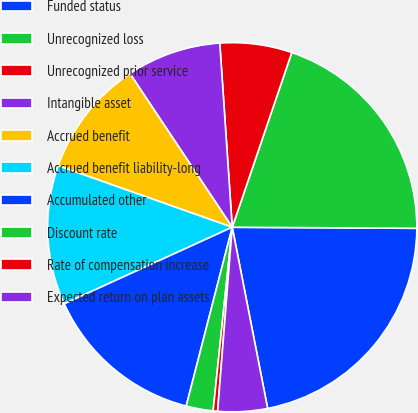Convert chart. <chart><loc_0><loc_0><loc_500><loc_500><pie_chart><fcel>Funded status<fcel>Unrecognized loss<fcel>Unrecognized prior service<fcel>Intangible asset<fcel>Accrued benefit<fcel>Accrued benefit liability-long<fcel>Accumulated other<fcel>Discount rate<fcel>Rate of compensation increase<fcel>Expected return on plan assets<nl><fcel>21.83%<fcel>19.86%<fcel>6.3%<fcel>8.27%<fcel>10.24%<fcel>12.21%<fcel>14.18%<fcel>2.36%<fcel>0.39%<fcel>4.33%<nl></chart> 